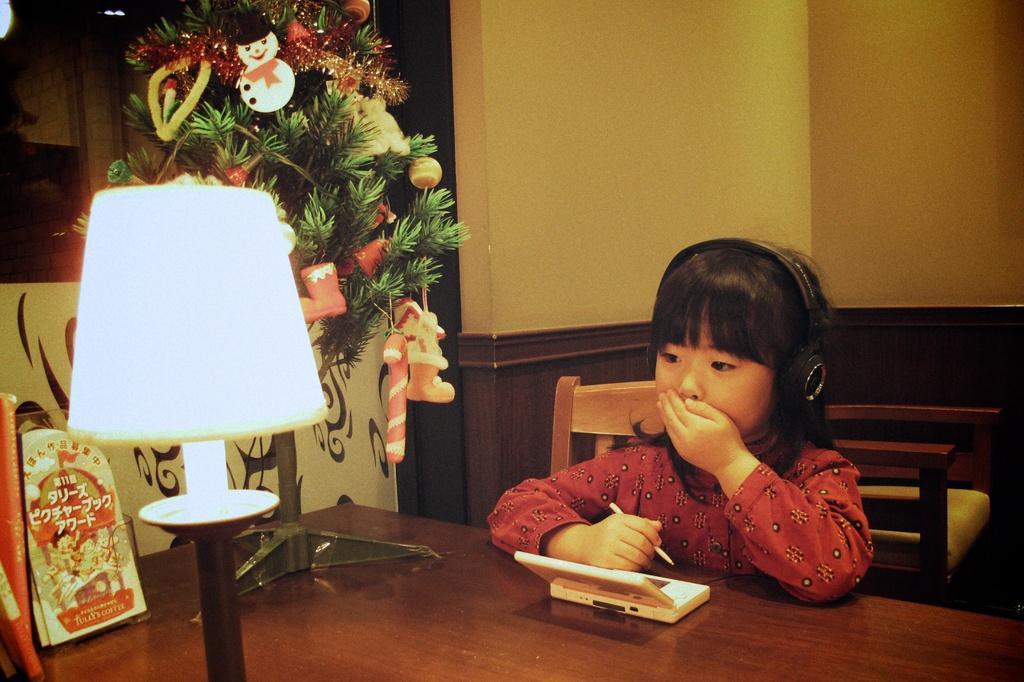Describe this image in one or two sentences. This image consists of table and chairs. There is a lamp on the left side. There is a Christmas tree on the left side. On the table there is a stand, lamp, a toy. Child sitting on the chair near the table, she is wearing headphones. 